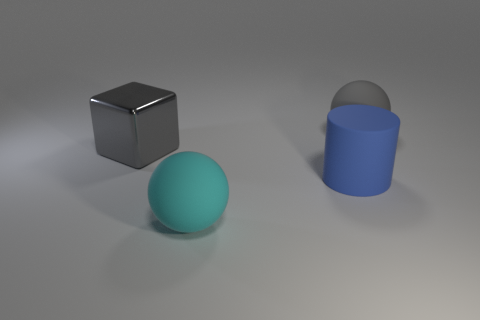How is the lighting in this scene affecting the appearance of the objects? The lighting creates subtle shadows and highlights, giving the objects a three-dimensional appearance and enhancing their textures. 